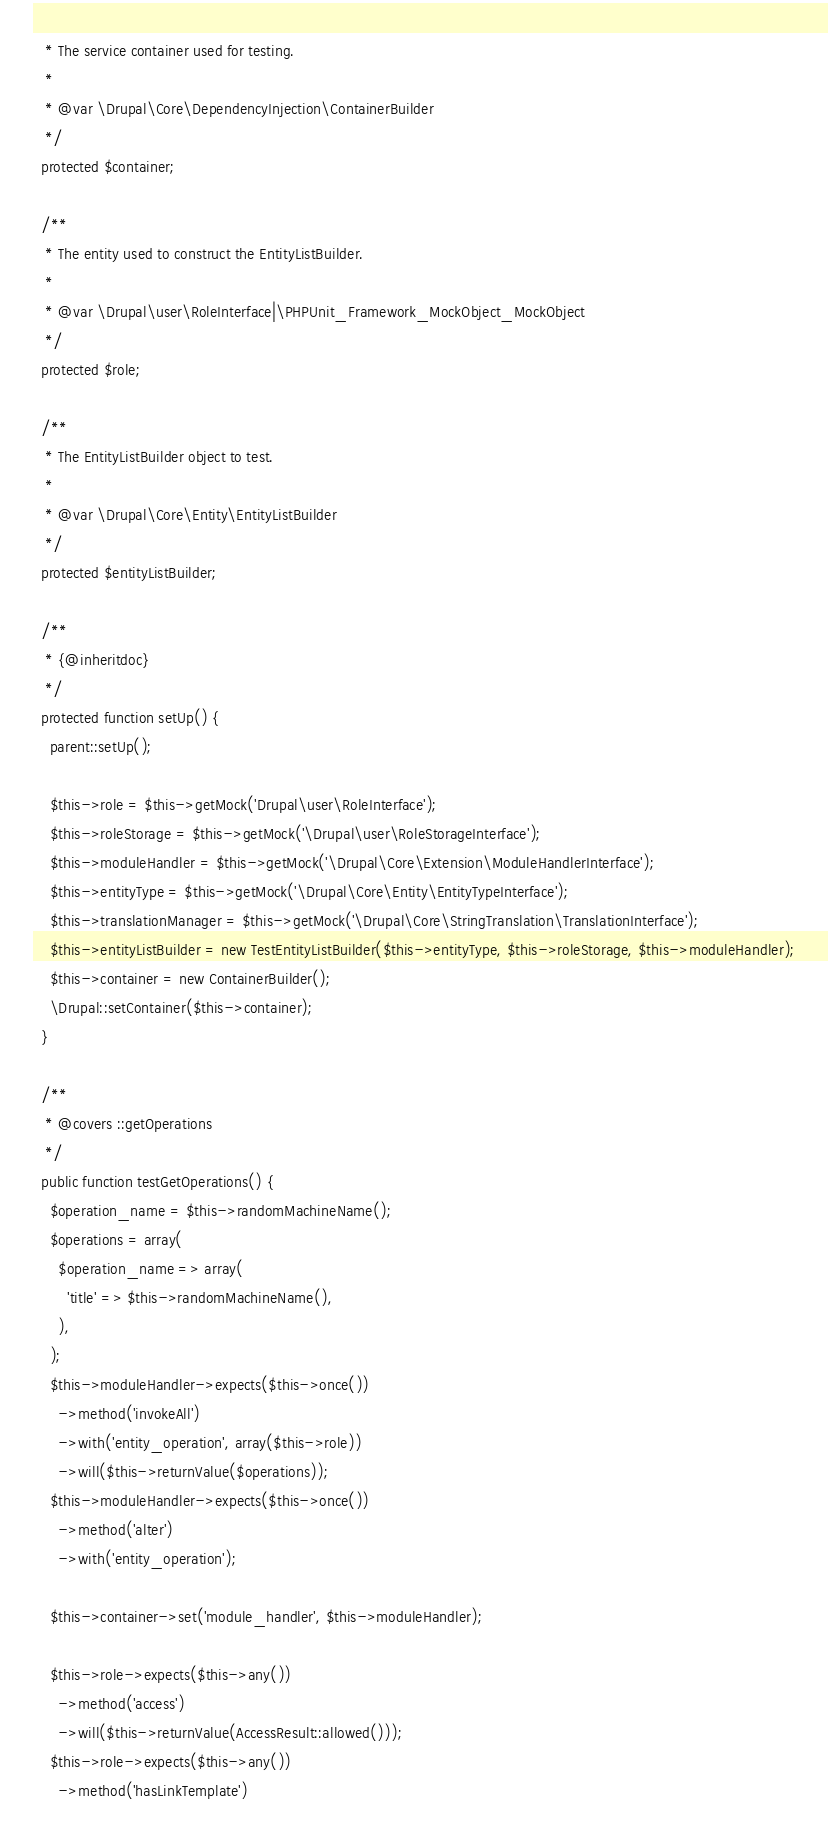<code> <loc_0><loc_0><loc_500><loc_500><_PHP_>   * The service container used for testing.
   *
   * @var \Drupal\Core\DependencyInjection\ContainerBuilder
   */
  protected $container;

  /**
   * The entity used to construct the EntityListBuilder.
   *
   * @var \Drupal\user\RoleInterface|\PHPUnit_Framework_MockObject_MockObject
   */
  protected $role;

  /**
   * The EntityListBuilder object to test.
   *
   * @var \Drupal\Core\Entity\EntityListBuilder
   */
  protected $entityListBuilder;

  /**
   * {@inheritdoc}
   */
  protected function setUp() {
    parent::setUp();

    $this->role = $this->getMock('Drupal\user\RoleInterface');
    $this->roleStorage = $this->getMock('\Drupal\user\RoleStorageInterface');
    $this->moduleHandler = $this->getMock('\Drupal\Core\Extension\ModuleHandlerInterface');
    $this->entityType = $this->getMock('\Drupal\Core\Entity\EntityTypeInterface');
    $this->translationManager = $this->getMock('\Drupal\Core\StringTranslation\TranslationInterface');
    $this->entityListBuilder = new TestEntityListBuilder($this->entityType, $this->roleStorage, $this->moduleHandler);
    $this->container = new ContainerBuilder();
    \Drupal::setContainer($this->container);
  }

  /**
   * @covers ::getOperations
   */
  public function testGetOperations() {
    $operation_name = $this->randomMachineName();
    $operations = array(
      $operation_name => array(
        'title' => $this->randomMachineName(),
      ),
    );
    $this->moduleHandler->expects($this->once())
      ->method('invokeAll')
      ->with('entity_operation', array($this->role))
      ->will($this->returnValue($operations));
    $this->moduleHandler->expects($this->once())
      ->method('alter')
      ->with('entity_operation');

    $this->container->set('module_handler', $this->moduleHandler);

    $this->role->expects($this->any())
      ->method('access')
      ->will($this->returnValue(AccessResult::allowed()));
    $this->role->expects($this->any())
      ->method('hasLinkTemplate')</code> 